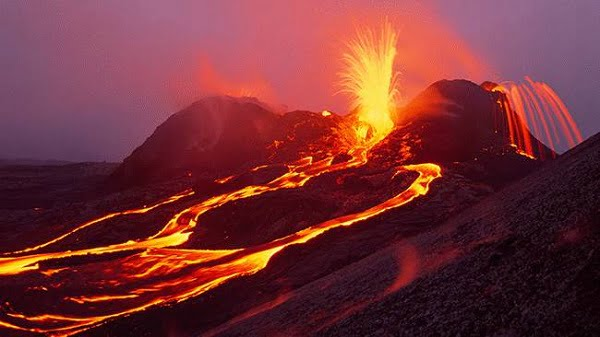What might be the immediate impacts of this eruption on the surrounding environment? The immediate impacts of this eruption are likely quite severe. The intense heat from the flowing lava can ignite fires, destroy vegetation, and alter the landforms. Ash and volcanic gases released into the atmosphere can harm air quality and affect both local wildlife and human populations. Additionally, lava flows can radically change the landscape by creating new rock formations and altering waterways. 